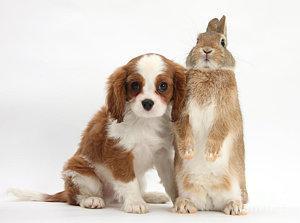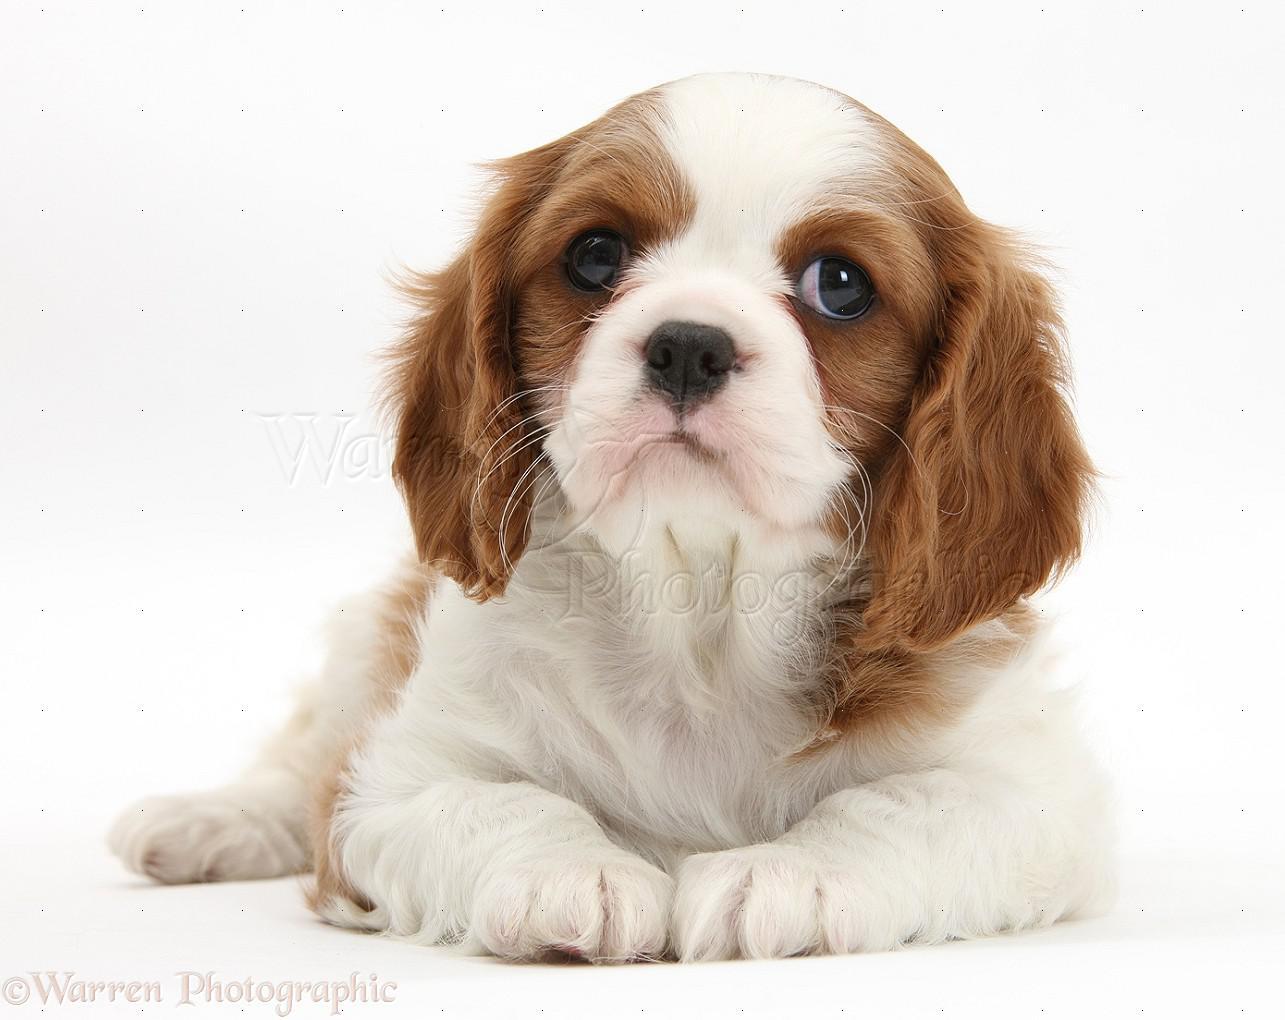The first image is the image on the left, the second image is the image on the right. For the images shown, is this caption "Two animals, including at least one spaniel dog, pose side-by-side in one image." true? Answer yes or no. Yes. The first image is the image on the left, the second image is the image on the right. Evaluate the accuracy of this statement regarding the images: "There are three mammals visible". Is it true? Answer yes or no. Yes. 